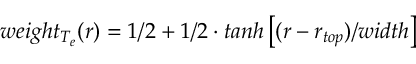<formula> <loc_0><loc_0><loc_500><loc_500>w e i g h t _ { T _ { e } } ( r ) = 1 / 2 + 1 / 2 \cdot t a n h \left [ ( r - r _ { t o p } ) / w i d t h \right ]</formula> 